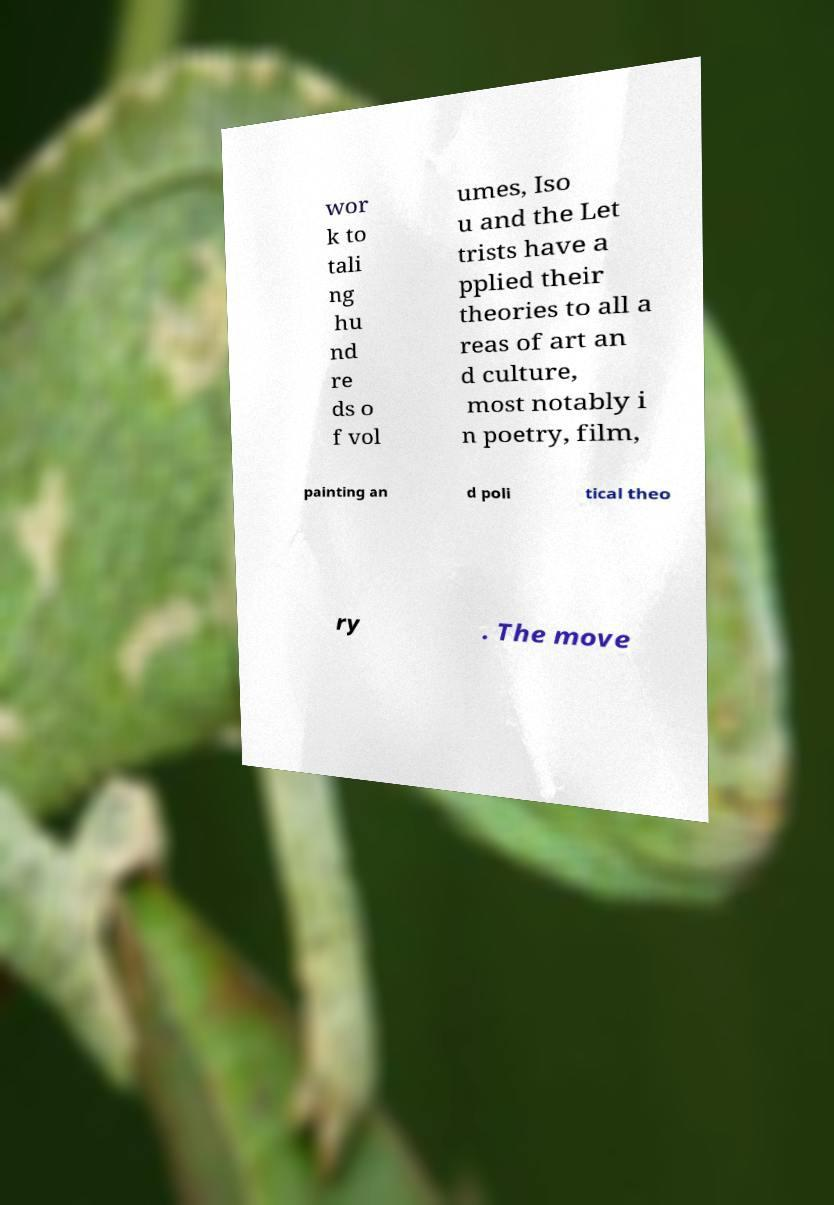Please read and relay the text visible in this image. What does it say? wor k to tali ng hu nd re ds o f vol umes, Iso u and the Let trists have a pplied their theories to all a reas of art an d culture, most notably i n poetry, film, painting an d poli tical theo ry . The move 